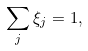<formula> <loc_0><loc_0><loc_500><loc_500>\sum _ { j } \xi _ { j } = 1 ,</formula> 